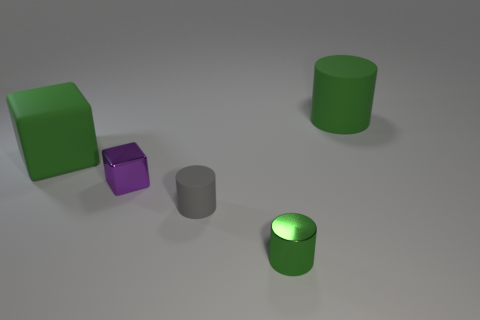Add 5 small gray objects. How many objects exist? 10 Subtract all blocks. How many objects are left? 3 Add 4 tiny gray things. How many tiny gray things are left? 5 Add 5 small green things. How many small green things exist? 6 Subtract 0 blue blocks. How many objects are left? 5 Subtract all cylinders. Subtract all small gray matte spheres. How many objects are left? 2 